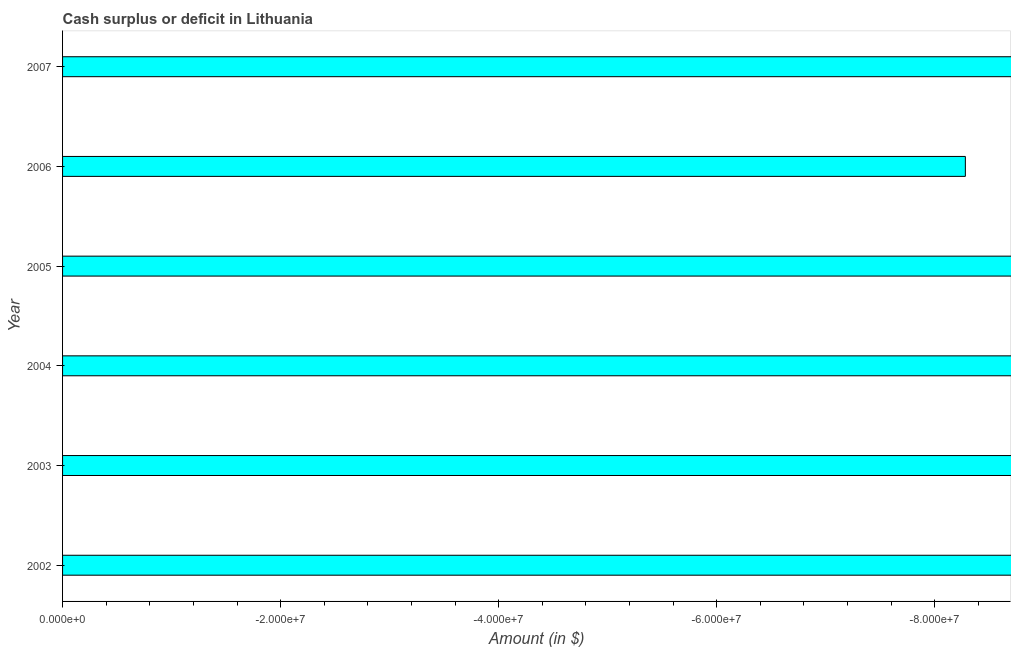What is the title of the graph?
Give a very brief answer. Cash surplus or deficit in Lithuania. What is the label or title of the X-axis?
Provide a short and direct response. Amount (in $). What is the cash surplus or deficit in 2006?
Provide a succinct answer. 0. What is the sum of the cash surplus or deficit?
Your response must be concise. 0. What is the median cash surplus or deficit?
Your answer should be very brief. 0. In how many years, is the cash surplus or deficit greater than -68000000 $?
Provide a succinct answer. 0. How many years are there in the graph?
Provide a short and direct response. 6. What is the Amount (in $) in 2002?
Offer a terse response. 0. What is the Amount (in $) in 2003?
Provide a succinct answer. 0. What is the Amount (in $) in 2004?
Provide a succinct answer. 0. What is the Amount (in $) of 2005?
Provide a short and direct response. 0. 